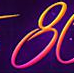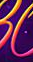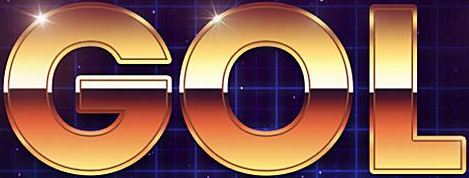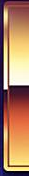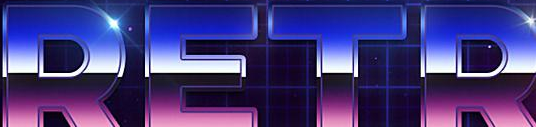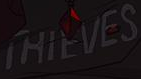Read the text content from these images in order, separated by a semicolon. 8; #; GOL; #; RETR; THIEVES 